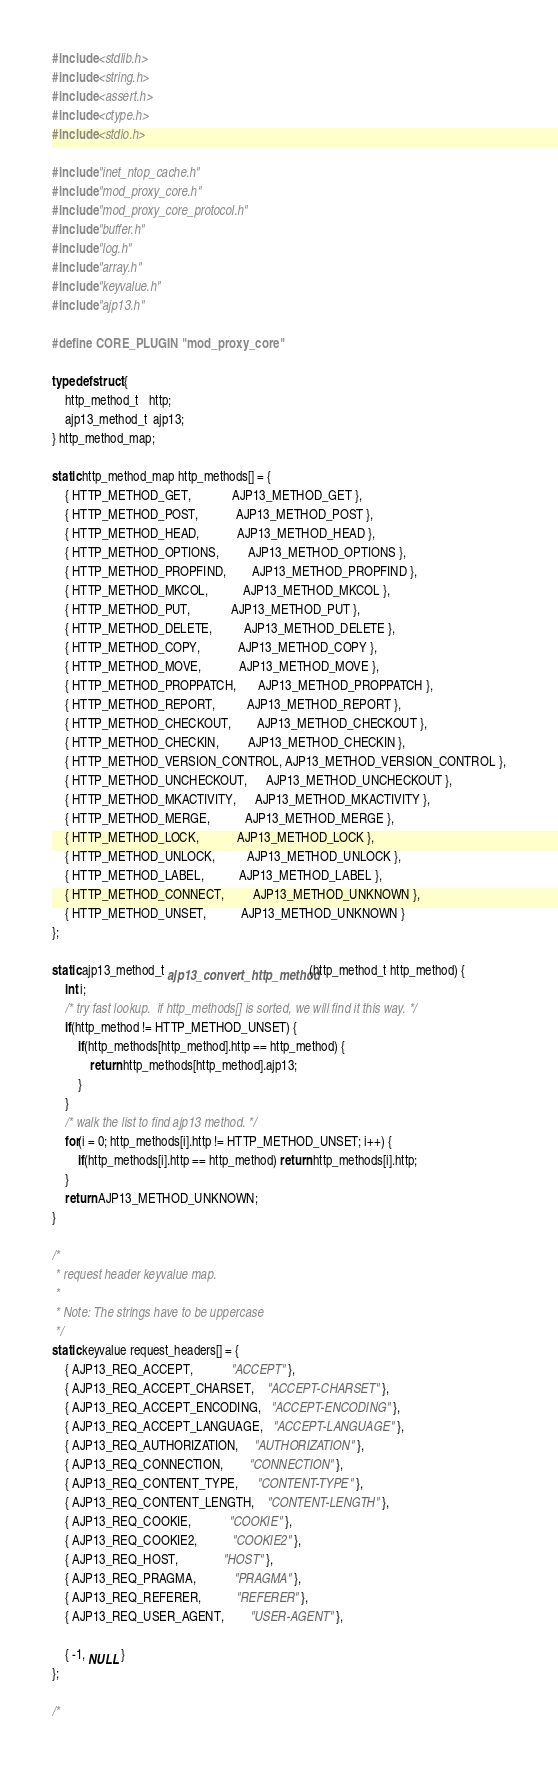Convert code to text. <code><loc_0><loc_0><loc_500><loc_500><_C_>#include <stdlib.h>
#include <string.h>
#include <assert.h>
#include <ctype.h>
#include <stdio.h>

#include "inet_ntop_cache.h"
#include "mod_proxy_core.h"
#include "mod_proxy_core_protocol.h"
#include "buffer.h"
#include "log.h"
#include "array.h"
#include "keyvalue.h"
#include "ajp13.h"

#define CORE_PLUGIN "mod_proxy_core"

typedef struct {
	http_method_t   http;
	ajp13_method_t  ajp13;
} http_method_map;

static http_method_map http_methods[] = {
	{ HTTP_METHOD_GET,             AJP13_METHOD_GET },
	{ HTTP_METHOD_POST,            AJP13_METHOD_POST },
	{ HTTP_METHOD_HEAD,            AJP13_METHOD_HEAD },
	{ HTTP_METHOD_OPTIONS,         AJP13_METHOD_OPTIONS },
	{ HTTP_METHOD_PROPFIND,        AJP13_METHOD_PROPFIND },
	{ HTTP_METHOD_MKCOL,           AJP13_METHOD_MKCOL },
	{ HTTP_METHOD_PUT,             AJP13_METHOD_PUT },
	{ HTTP_METHOD_DELETE,          AJP13_METHOD_DELETE },
	{ HTTP_METHOD_COPY,            AJP13_METHOD_COPY },
	{ HTTP_METHOD_MOVE,            AJP13_METHOD_MOVE },
	{ HTTP_METHOD_PROPPATCH,       AJP13_METHOD_PROPPATCH },
	{ HTTP_METHOD_REPORT,          AJP13_METHOD_REPORT },
	{ HTTP_METHOD_CHECKOUT,        AJP13_METHOD_CHECKOUT },
	{ HTTP_METHOD_CHECKIN,         AJP13_METHOD_CHECKIN },
	{ HTTP_METHOD_VERSION_CONTROL, AJP13_METHOD_VERSION_CONTROL },
	{ HTTP_METHOD_UNCHECKOUT,      AJP13_METHOD_UNCHECKOUT },
	{ HTTP_METHOD_MKACTIVITY,      AJP13_METHOD_MKACTIVITY },
	{ HTTP_METHOD_MERGE,           AJP13_METHOD_MERGE },
	{ HTTP_METHOD_LOCK,            AJP13_METHOD_LOCK },
	{ HTTP_METHOD_UNLOCK,          AJP13_METHOD_UNLOCK },
	{ HTTP_METHOD_LABEL,           AJP13_METHOD_LABEL },
	{ HTTP_METHOD_CONNECT,         AJP13_METHOD_UNKNOWN },
	{ HTTP_METHOD_UNSET,           AJP13_METHOD_UNKNOWN }
};

static ajp13_method_t ajp13_convert_http_method(http_method_t http_method) {
	int i;
	/* try fast lookup.  if http_methods[] is sorted, we will find it this way. */
	if(http_method != HTTP_METHOD_UNSET) {
		if(http_methods[http_method].http == http_method) {
			return http_methods[http_method].ajp13;
		}
	}
	/* walk the list to find ajp13 method. */
	for(i = 0; http_methods[i].http != HTTP_METHOD_UNSET; i++) {
		if(http_methods[i].http == http_method) return http_methods[i].http;
	}
	return AJP13_METHOD_UNKNOWN;
}

/*
 * request header keyvalue map.
 *
 * Note: The strings have to be uppercase
 */
static keyvalue request_headers[] = {
	{ AJP13_REQ_ACCEPT,            "ACCEPT" },
	{ AJP13_REQ_ACCEPT_CHARSET,    "ACCEPT-CHARSET" },
	{ AJP13_REQ_ACCEPT_ENCODING,   "ACCEPT-ENCODING" },
	{ AJP13_REQ_ACCEPT_LANGUAGE,   "ACCEPT-LANGUAGE" },
	{ AJP13_REQ_AUTHORIZATION,     "AUTHORIZATION" },
	{ AJP13_REQ_CONNECTION,        "CONNECTION" },
	{ AJP13_REQ_CONTENT_TYPE,      "CONTENT-TYPE" },
	{ AJP13_REQ_CONTENT_LENGTH,    "CONTENT-LENGTH" },
	{ AJP13_REQ_COOKIE,            "COOKIE" },
	{ AJP13_REQ_COOKIE2,           "COOKIE2" },
	{ AJP13_REQ_HOST,              "HOST" },
	{ AJP13_REQ_PRAGMA,            "PRAGMA" },
	{ AJP13_REQ_REFERER,           "REFERER" },
	{ AJP13_REQ_USER_AGENT,        "USER-AGENT" },

	{ -1, NULL }
};

/*</code> 